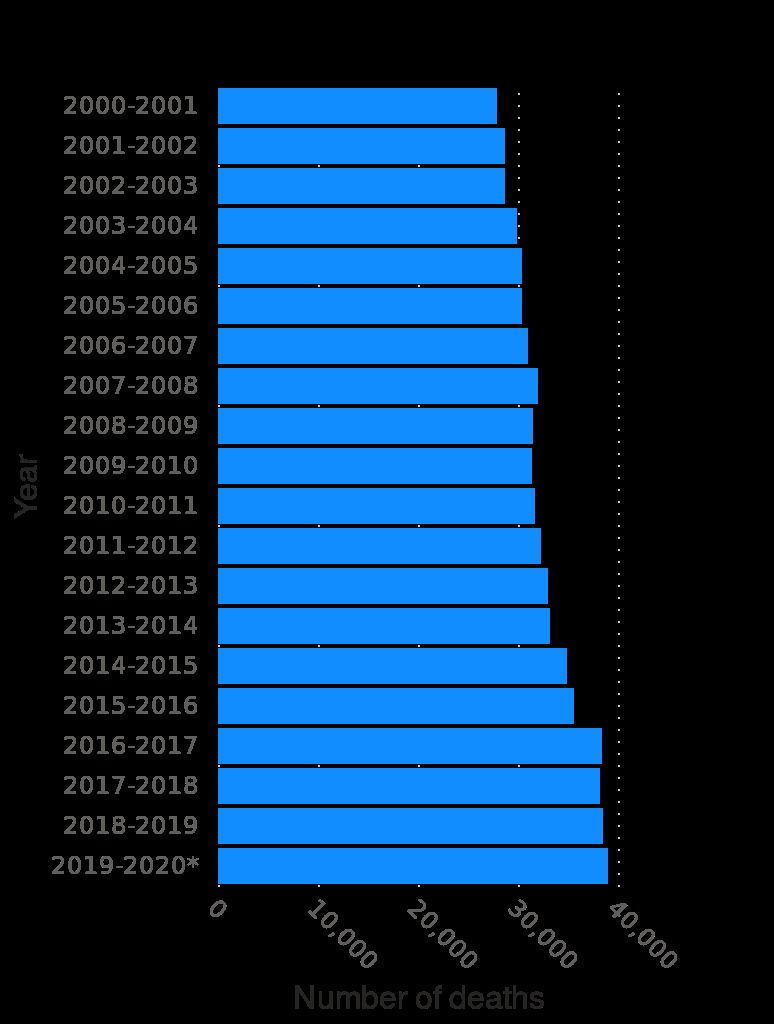<image>
please describe the details of the chart Here a is a bar plot titled Number of deaths in British Columbia , Canada from 2001 to 2020. The x-axis shows Number of deaths while the y-axis measures Year. What geographical region does the bar plot represent? The bar plot represents the number of deaths in British Columbia, Canada. Does the line plot titled Number of deaths in British Columbia, Canada from 2001 to 2020 show the y-axis as Number of deaths and the x-axis as Year? No.Here a is a bar plot titled Number of deaths in British Columbia , Canada from 2001 to 2020. The x-axis shows Number of deaths while the y-axis measures Year. 